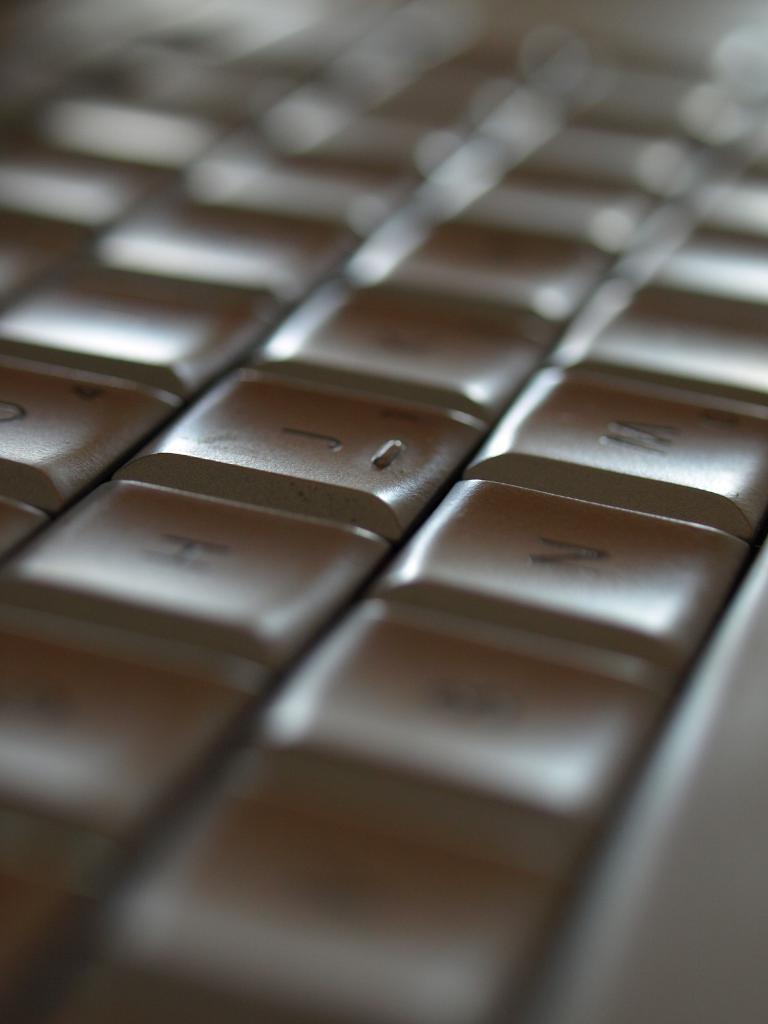How would you summarize this image in a sentence or two? In this picture, there is a keyboard. 